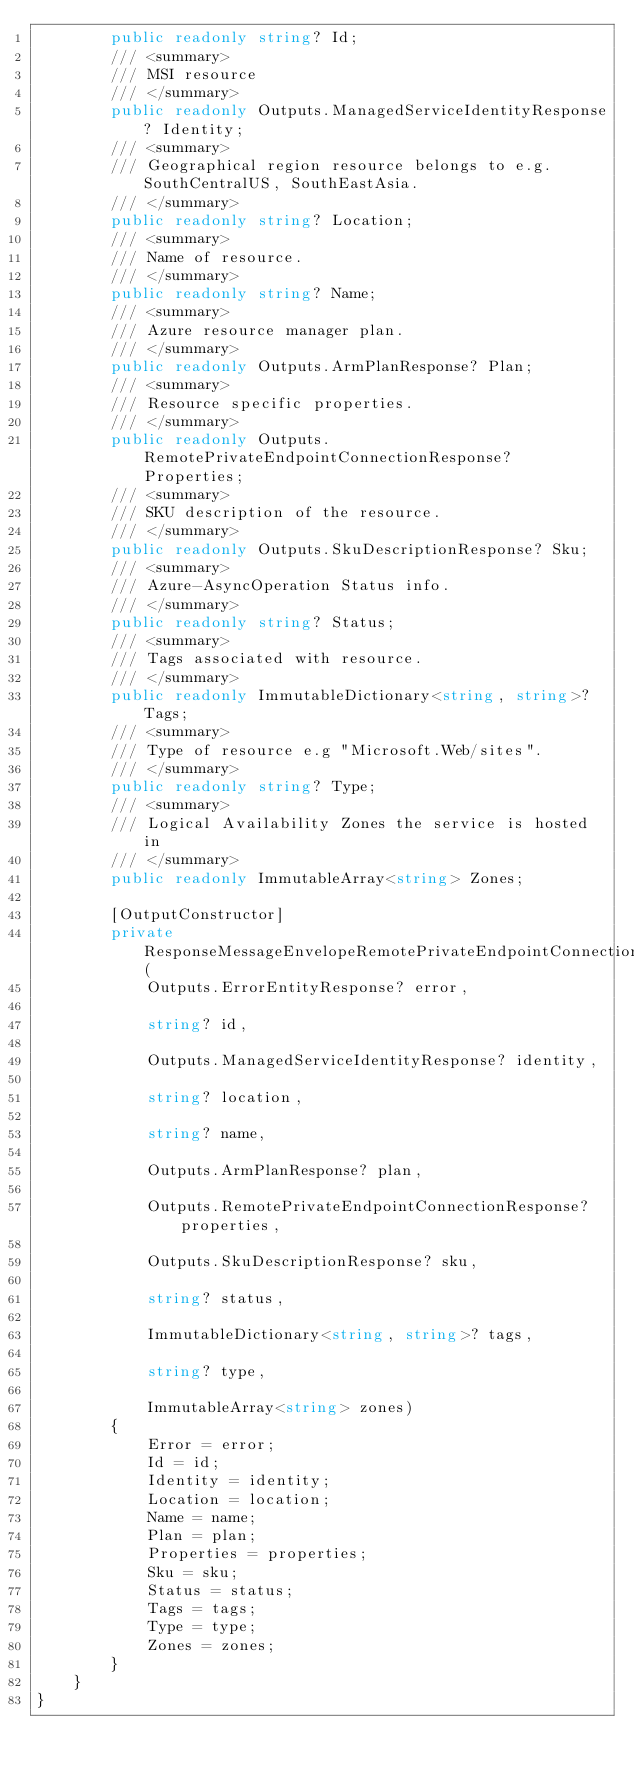Convert code to text. <code><loc_0><loc_0><loc_500><loc_500><_C#_>        public readonly string? Id;
        /// <summary>
        /// MSI resource
        /// </summary>
        public readonly Outputs.ManagedServiceIdentityResponse? Identity;
        /// <summary>
        /// Geographical region resource belongs to e.g. SouthCentralUS, SouthEastAsia.
        /// </summary>
        public readonly string? Location;
        /// <summary>
        /// Name of resource.
        /// </summary>
        public readonly string? Name;
        /// <summary>
        /// Azure resource manager plan.
        /// </summary>
        public readonly Outputs.ArmPlanResponse? Plan;
        /// <summary>
        /// Resource specific properties.
        /// </summary>
        public readonly Outputs.RemotePrivateEndpointConnectionResponse? Properties;
        /// <summary>
        /// SKU description of the resource.
        /// </summary>
        public readonly Outputs.SkuDescriptionResponse? Sku;
        /// <summary>
        /// Azure-AsyncOperation Status info.
        /// </summary>
        public readonly string? Status;
        /// <summary>
        /// Tags associated with resource.
        /// </summary>
        public readonly ImmutableDictionary<string, string>? Tags;
        /// <summary>
        /// Type of resource e.g "Microsoft.Web/sites".
        /// </summary>
        public readonly string? Type;
        /// <summary>
        /// Logical Availability Zones the service is hosted in
        /// </summary>
        public readonly ImmutableArray<string> Zones;

        [OutputConstructor]
        private ResponseMessageEnvelopeRemotePrivateEndpointConnectionResponse(
            Outputs.ErrorEntityResponse? error,

            string? id,

            Outputs.ManagedServiceIdentityResponse? identity,

            string? location,

            string? name,

            Outputs.ArmPlanResponse? plan,

            Outputs.RemotePrivateEndpointConnectionResponse? properties,

            Outputs.SkuDescriptionResponse? sku,

            string? status,

            ImmutableDictionary<string, string>? tags,

            string? type,

            ImmutableArray<string> zones)
        {
            Error = error;
            Id = id;
            Identity = identity;
            Location = location;
            Name = name;
            Plan = plan;
            Properties = properties;
            Sku = sku;
            Status = status;
            Tags = tags;
            Type = type;
            Zones = zones;
        }
    }
}
</code> 